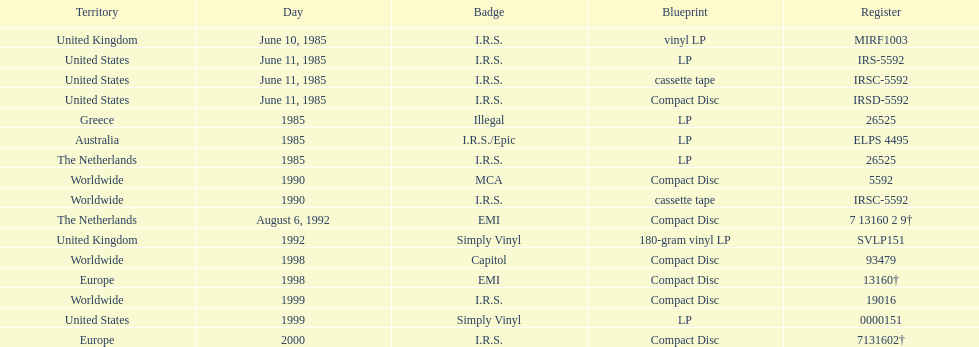In which sole region is the vinyl lp format available? United Kingdom. 